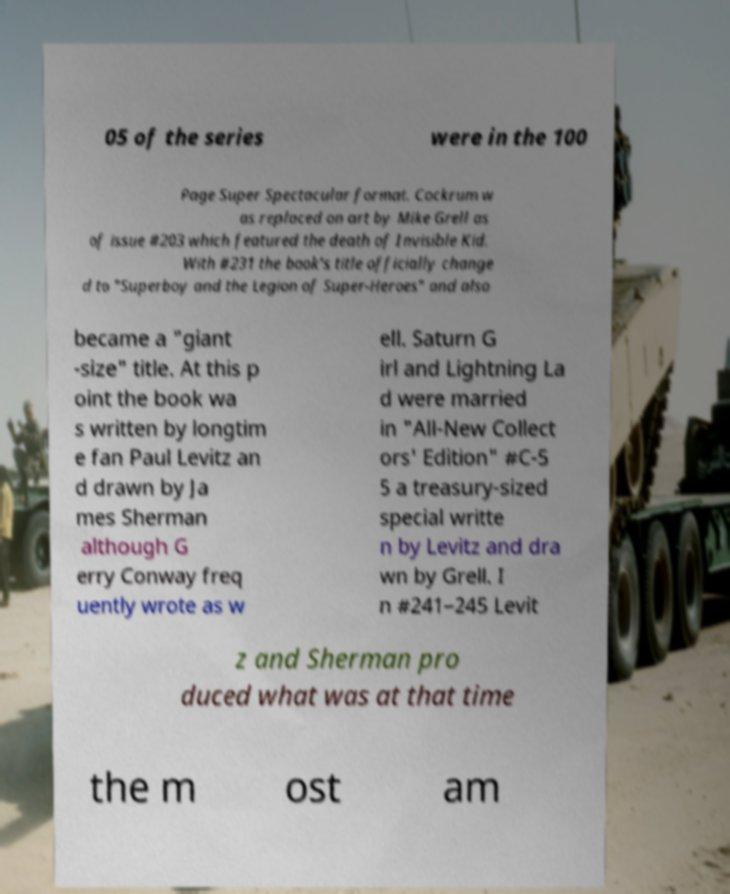There's text embedded in this image that I need extracted. Can you transcribe it verbatim? 05 of the series were in the 100 Page Super Spectacular format. Cockrum w as replaced on art by Mike Grell as of issue #203 which featured the death of Invisible Kid. With #231 the book's title officially change d to "Superboy and the Legion of Super-Heroes" and also became a "giant -size" title. At this p oint the book wa s written by longtim e fan Paul Levitz an d drawn by Ja mes Sherman although G erry Conway freq uently wrote as w ell. Saturn G irl and Lightning La d were married in "All-New Collect ors' Edition" #C-5 5 a treasury-sized special writte n by Levitz and dra wn by Grell. I n #241–245 Levit z and Sherman pro duced what was at that time the m ost am 